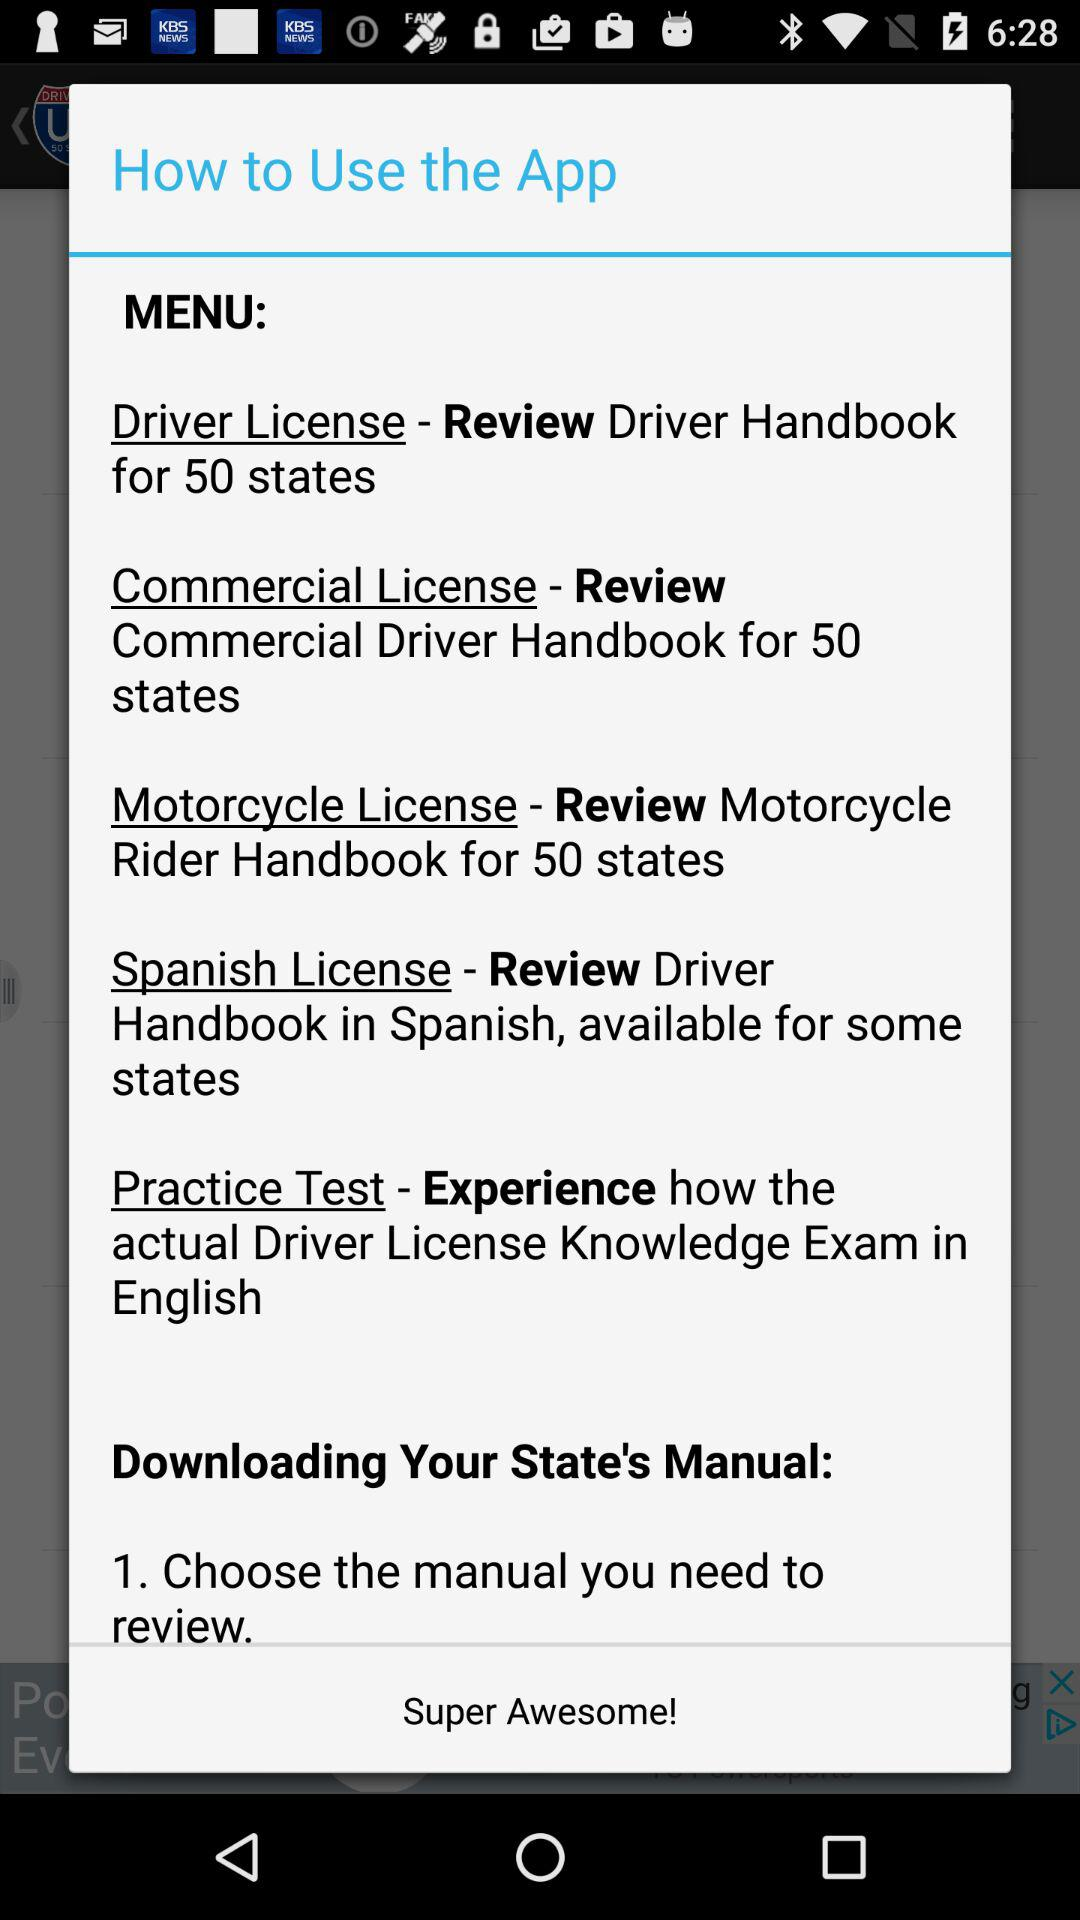In which language is the driver's handbook available for some states? The driver's handbook is available in Spanish. 